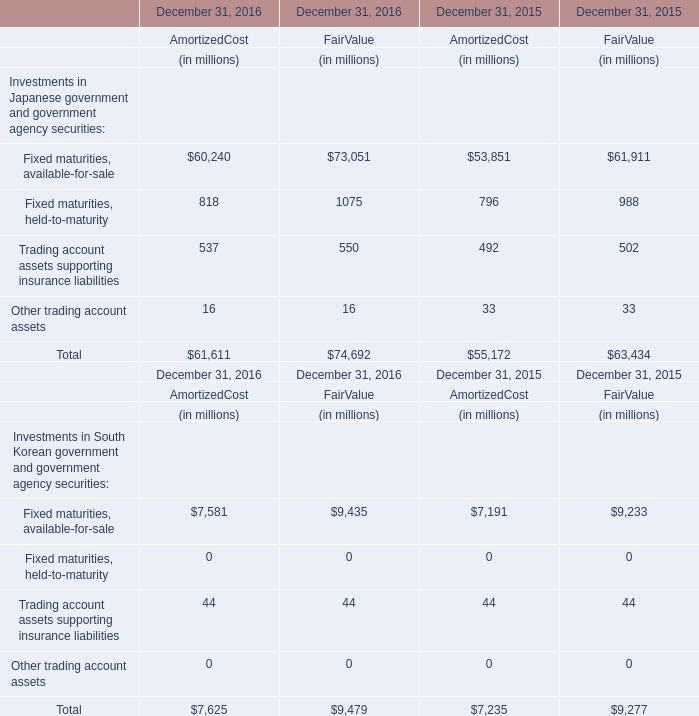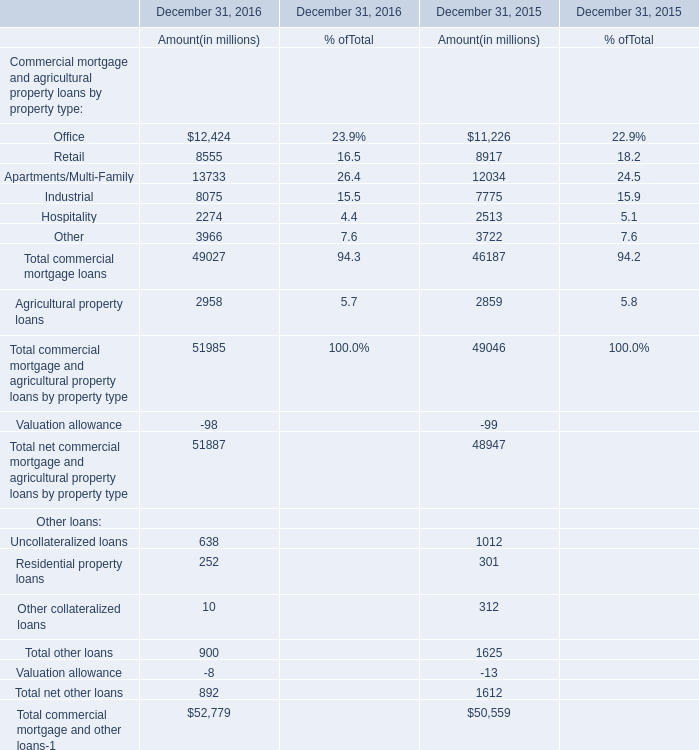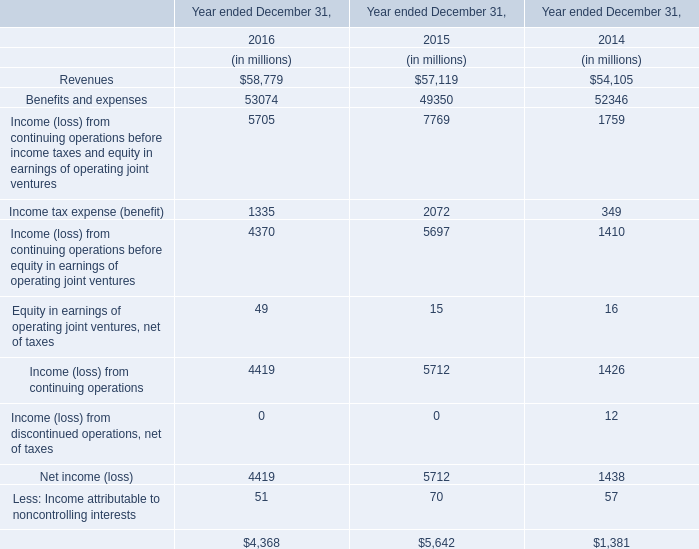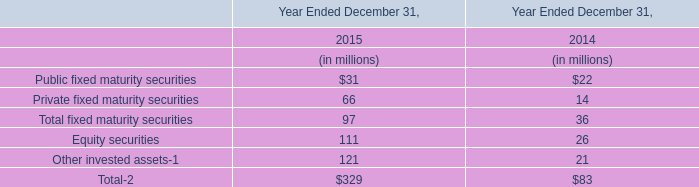What's the sum of all Office that are positive in amount? (in million) 
Computations: (12424 + 11226)
Answer: 23650.0. 